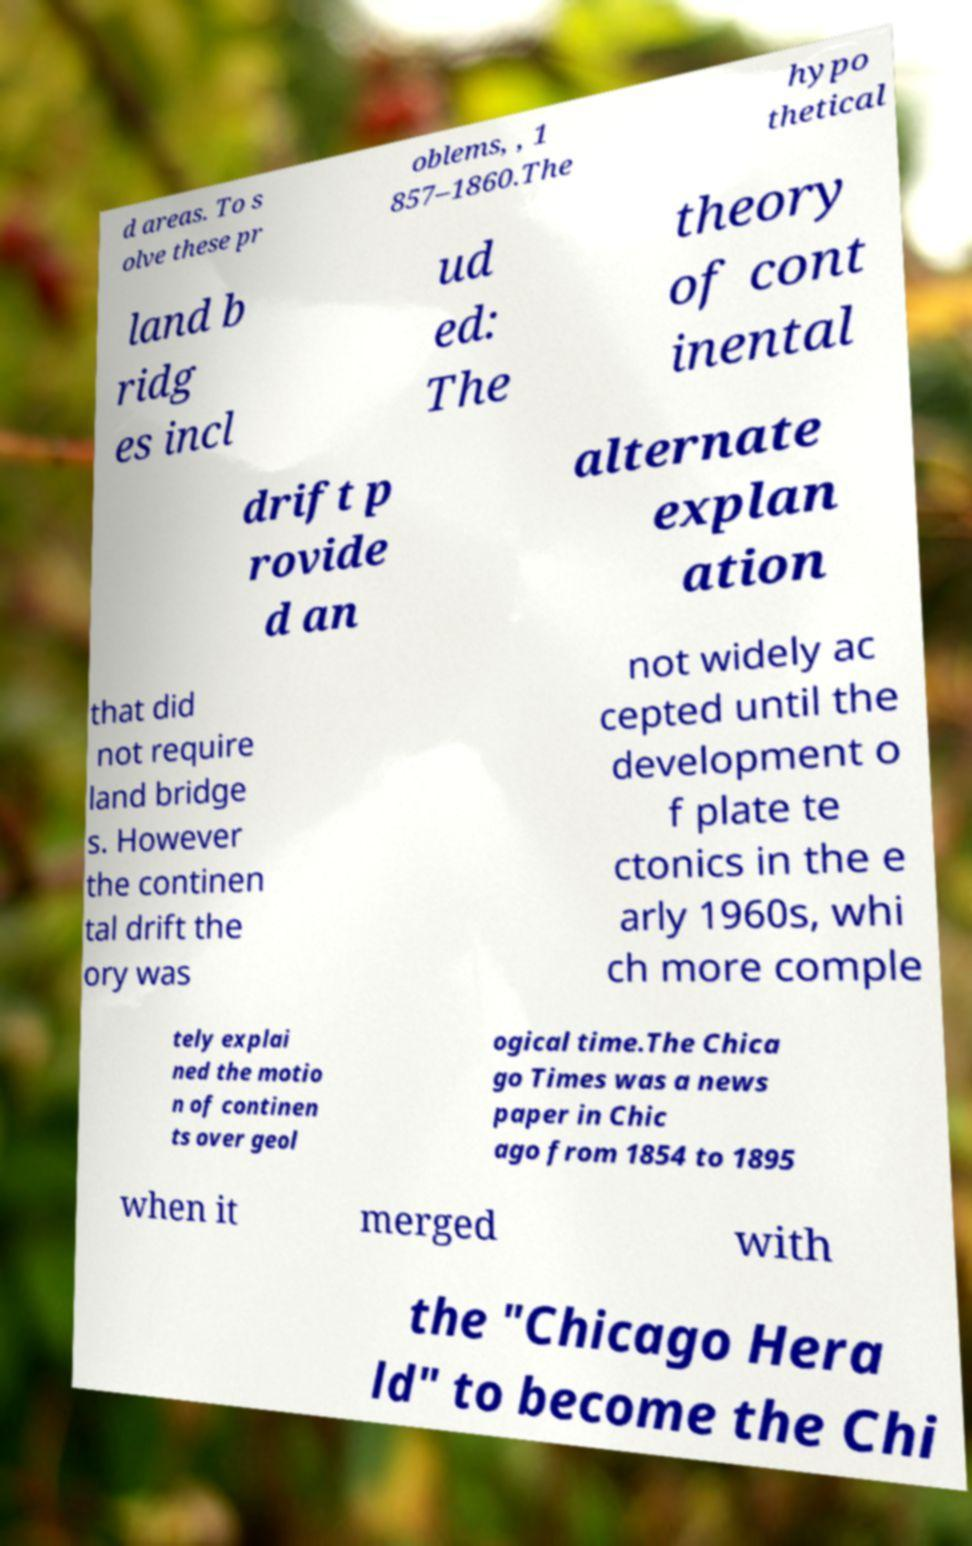For documentation purposes, I need the text within this image transcribed. Could you provide that? d areas. To s olve these pr oblems, , 1 857–1860.The hypo thetical land b ridg es incl ud ed: The theory of cont inental drift p rovide d an alternate explan ation that did not require land bridge s. However the continen tal drift the ory was not widely ac cepted until the development o f plate te ctonics in the e arly 1960s, whi ch more comple tely explai ned the motio n of continen ts over geol ogical time.The Chica go Times was a news paper in Chic ago from 1854 to 1895 when it merged with the "Chicago Hera ld" to become the Chi 